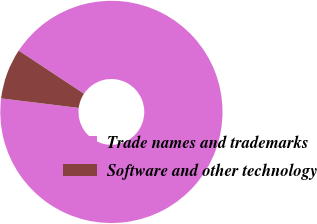Convert chart to OTSL. <chart><loc_0><loc_0><loc_500><loc_500><pie_chart><fcel>Trade names and trademarks<fcel>Software and other technology<nl><fcel>92.64%<fcel>7.36%<nl></chart> 